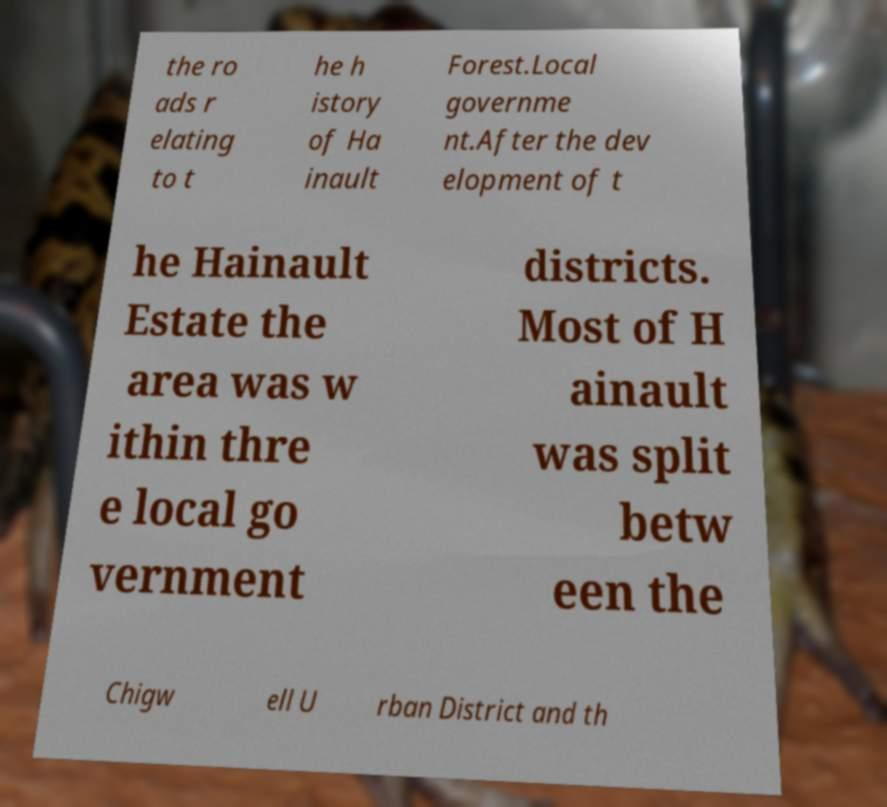Please read and relay the text visible in this image. What does it say? the ro ads r elating to t he h istory of Ha inault Forest.Local governme nt.After the dev elopment of t he Hainault Estate the area was w ithin thre e local go vernment districts. Most of H ainault was split betw een the Chigw ell U rban District and th 